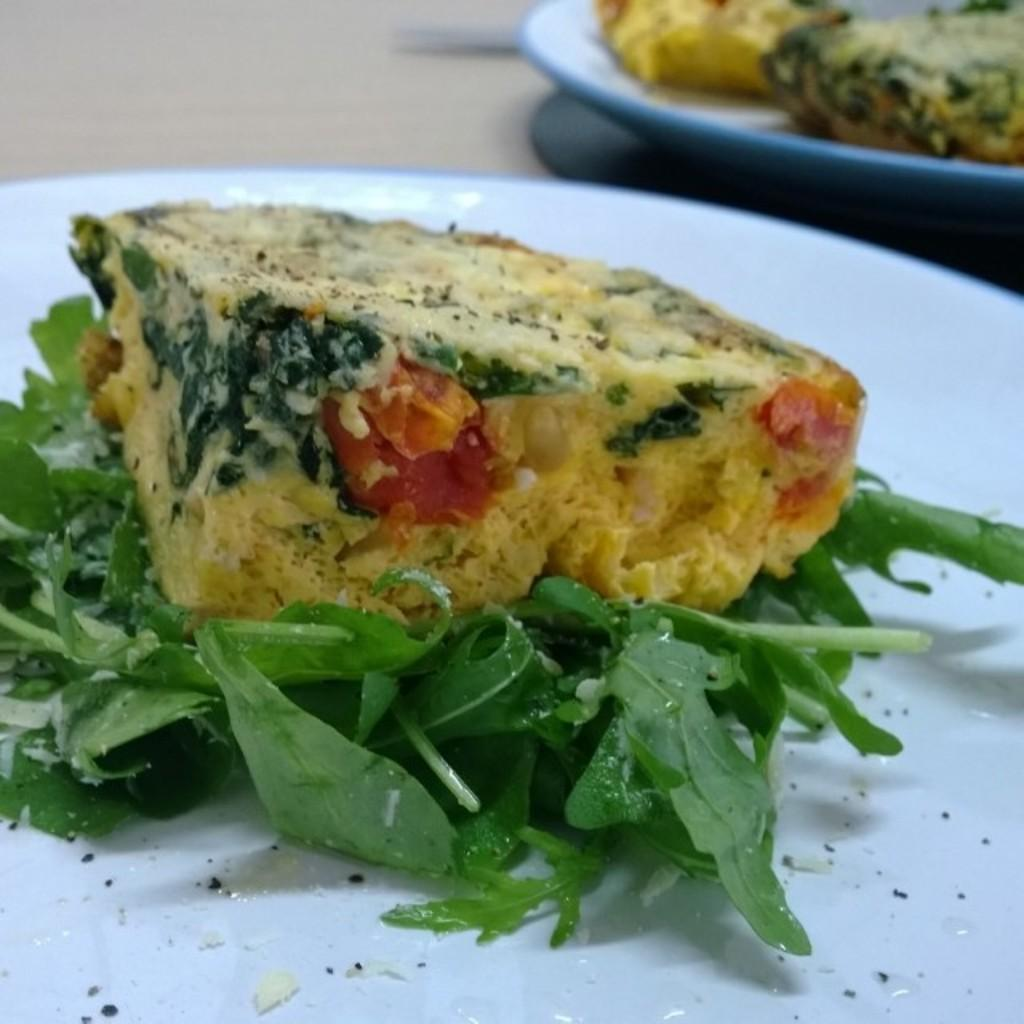What objects are present on the surface in the image? There are plates in the image. What is on the plates? There is food on the plates. Can you describe the surface on which the plates and food are placed? The plates and food are on a surface. What type of twig can be seen in the image? There is no twig present in the image. What time of day is depicted in the image? The time of day cannot be determined from the image, as there are no clues or context provided. 